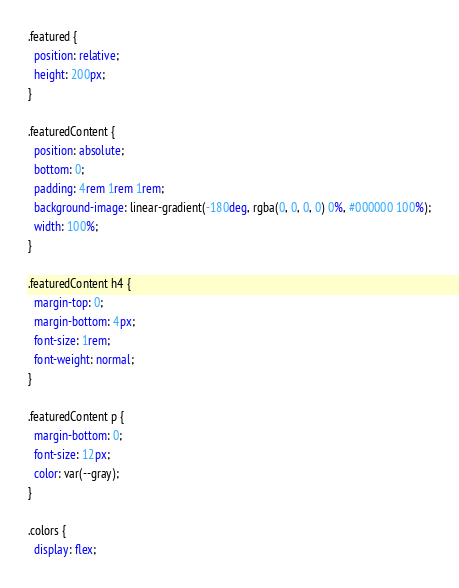<code> <loc_0><loc_0><loc_500><loc_500><_CSS_>.featured {
  position: relative;
  height: 200px;
}

.featuredContent {
  position: absolute;
  bottom: 0;
  padding: 4rem 1rem 1rem;
  background-image: linear-gradient(-180deg, rgba(0, 0, 0, 0) 0%, #000000 100%);
  width: 100%;
}

.featuredContent h4 {
  margin-top: 0;
  margin-bottom: 4px;
  font-size: 1rem;
  font-weight: normal;
}

.featuredContent p {
  margin-bottom: 0;
  font-size: 12px;
  color: var(--gray);
}

.colors {
  display: flex;</code> 